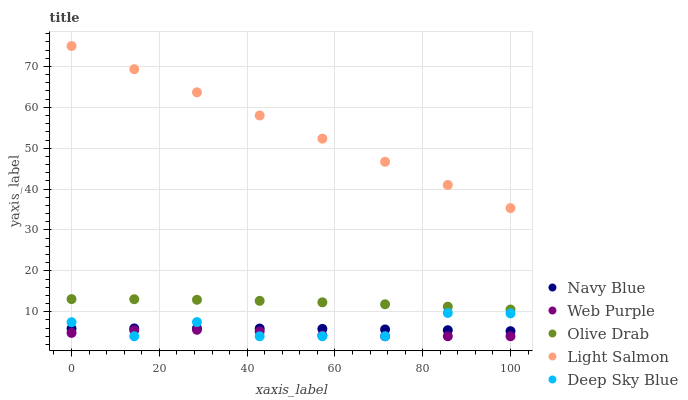Does Web Purple have the minimum area under the curve?
Answer yes or no. Yes. Does Light Salmon have the maximum area under the curve?
Answer yes or no. Yes. Does Light Salmon have the minimum area under the curve?
Answer yes or no. No. Does Web Purple have the maximum area under the curve?
Answer yes or no. No. Is Light Salmon the smoothest?
Answer yes or no. Yes. Is Deep Sky Blue the roughest?
Answer yes or no. Yes. Is Web Purple the smoothest?
Answer yes or no. No. Is Web Purple the roughest?
Answer yes or no. No. Does Web Purple have the lowest value?
Answer yes or no. Yes. Does Light Salmon have the lowest value?
Answer yes or no. No. Does Light Salmon have the highest value?
Answer yes or no. Yes. Does Web Purple have the highest value?
Answer yes or no. No. Is Navy Blue less than Olive Drab?
Answer yes or no. Yes. Is Olive Drab greater than Navy Blue?
Answer yes or no. Yes. Does Deep Sky Blue intersect Web Purple?
Answer yes or no. Yes. Is Deep Sky Blue less than Web Purple?
Answer yes or no. No. Is Deep Sky Blue greater than Web Purple?
Answer yes or no. No. Does Navy Blue intersect Olive Drab?
Answer yes or no. No. 